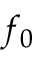<formula> <loc_0><loc_0><loc_500><loc_500>f _ { 0 }</formula> 